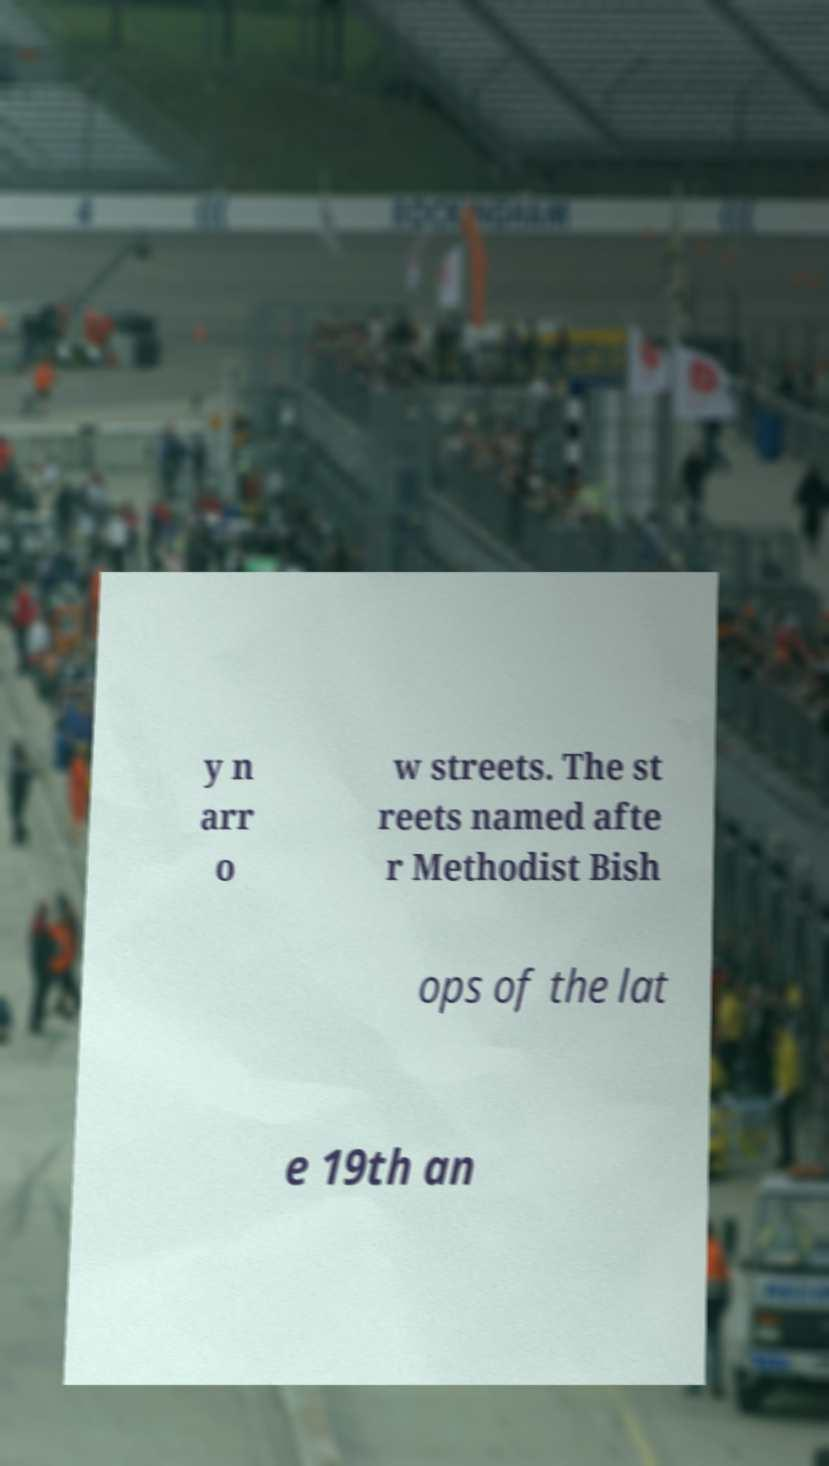Please read and relay the text visible in this image. What does it say? y n arr o w streets. The st reets named afte r Methodist Bish ops of the lat e 19th an 